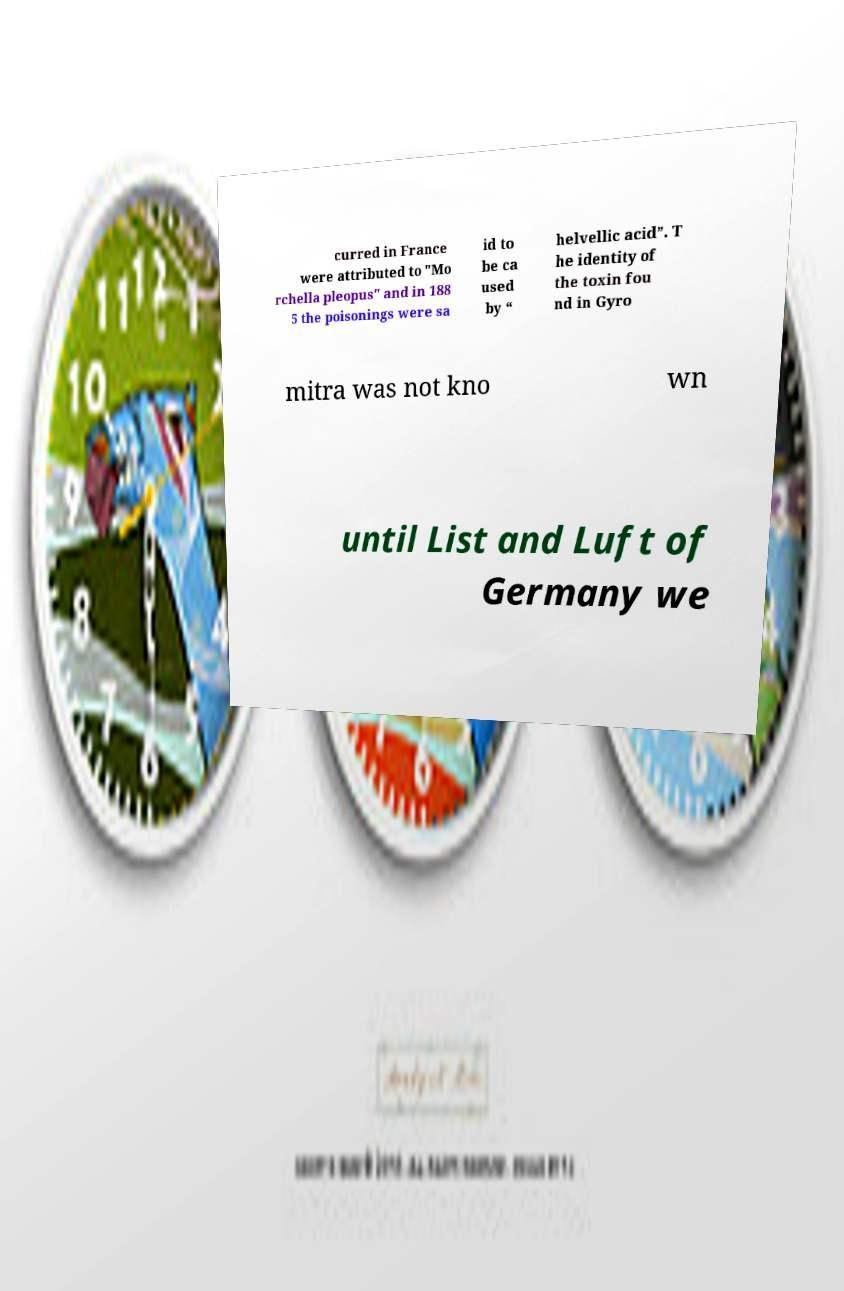There's text embedded in this image that I need extracted. Can you transcribe it verbatim? curred in France were attributed to "Mo rchella pleopus" and in 188 5 the poisonings were sa id to be ca used by “ helvellic acid”. T he identity of the toxin fou nd in Gyro mitra was not kno wn until List and Luft of Germany we 